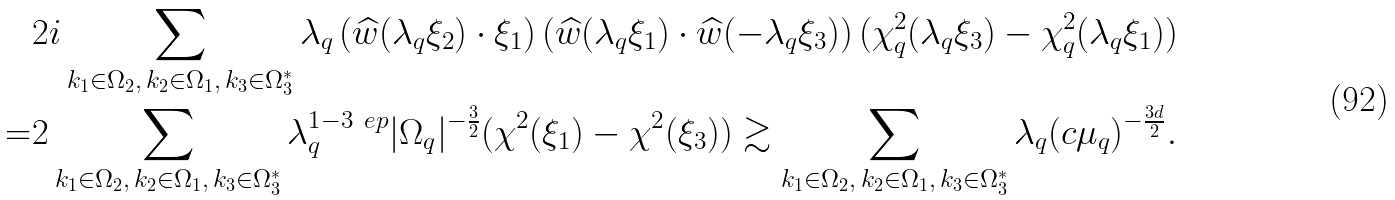Convert formula to latex. <formula><loc_0><loc_0><loc_500><loc_500>& 2 i \sum _ { k _ { 1 } \in \Omega _ { 2 } , \, k _ { 2 } \in \Omega _ { 1 } , \, k _ { 3 } \in \Omega _ { 3 } ^ { * } } \lambda _ { q } \left ( \widehat { w } ( \lambda _ { q } \xi _ { 2 } ) \cdot \xi _ { 1 } \right ) \left ( \widehat { w } ( \lambda _ { q } \xi _ { 1 } ) \cdot \widehat { w } ( - \lambda _ { q } \xi _ { 3 } ) \right ) ( \chi _ { q } ^ { 2 } ( \lambda _ { q } \xi _ { 3 } ) - \chi _ { q } ^ { 2 } ( \lambda _ { q } \xi _ { 1 } ) ) \\ = & 2 \sum _ { k _ { 1 } \in \Omega _ { 2 } , \, k _ { 2 } \in \Omega _ { 1 } , \, k _ { 3 } \in \Omega _ { 3 } ^ { * } } \lambda _ { q } ^ { 1 - 3 \ e p } | \Omega _ { q } | ^ { - \frac { 3 } { 2 } } ( \chi ^ { 2 } ( \xi _ { 1 } ) - \chi ^ { 2 } ( \xi _ { 3 } ) ) \gtrsim \sum _ { k _ { 1 } \in \Omega _ { 2 } , \, k _ { 2 } \in \Omega _ { 1 } , \, k _ { 3 } \in \Omega _ { 3 } ^ { * } } \lambda _ { q } ( c \mu _ { q } ) ^ { - \frac { 3 d } { 2 } } .</formula> 